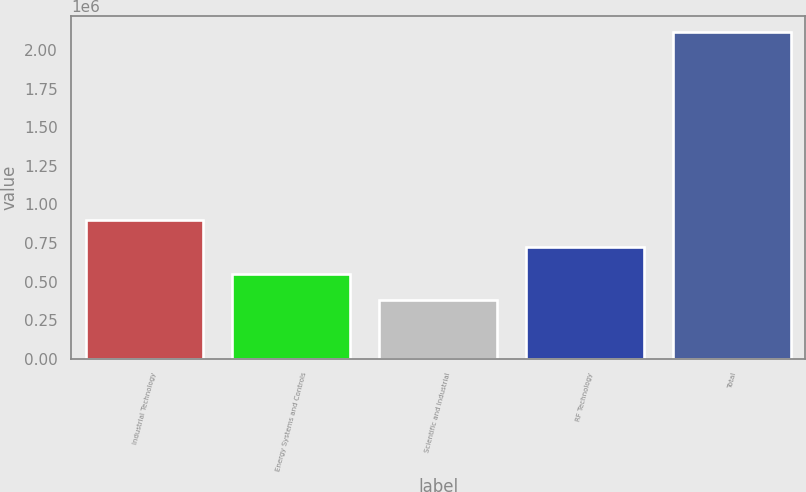Convert chart. <chart><loc_0><loc_0><loc_500><loc_500><bar_chart><fcel>Industrial Technology<fcel>Energy Systems and Controls<fcel>Scientific and Industrial<fcel>RF Technology<fcel>Total<nl><fcel>899757<fcel>551688<fcel>377653<fcel>725722<fcel>2.118e+06<nl></chart> 